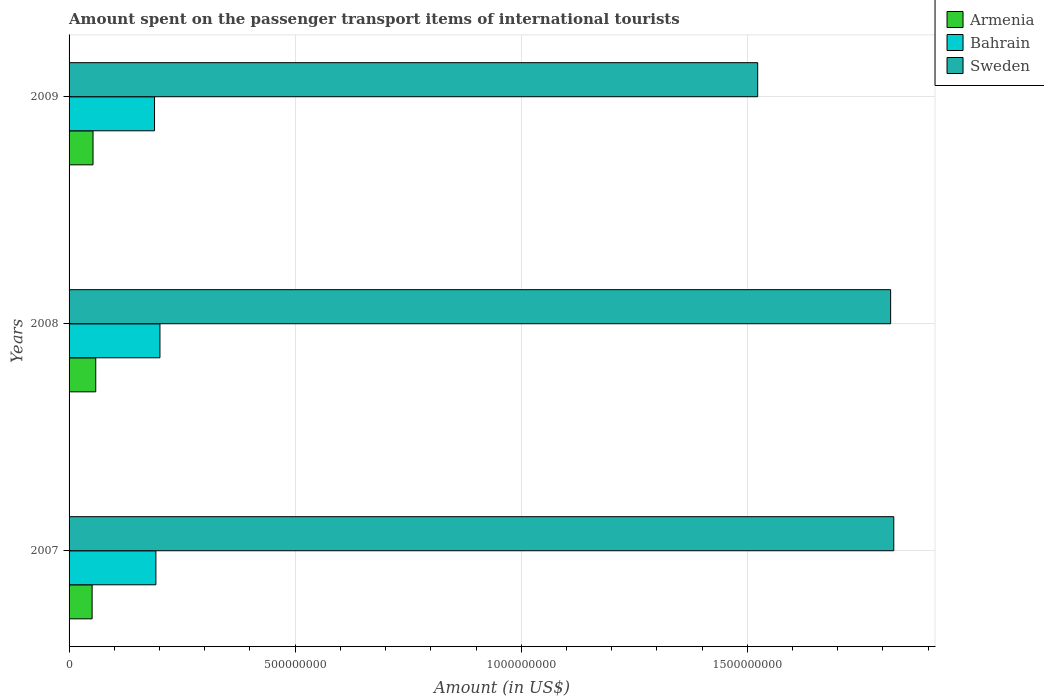How many different coloured bars are there?
Ensure brevity in your answer.  3. How many groups of bars are there?
Provide a short and direct response. 3. Are the number of bars per tick equal to the number of legend labels?
Your answer should be compact. Yes. Are the number of bars on each tick of the Y-axis equal?
Your response must be concise. Yes. How many bars are there on the 2nd tick from the top?
Your response must be concise. 3. How many bars are there on the 2nd tick from the bottom?
Your answer should be very brief. 3. In how many cases, is the number of bars for a given year not equal to the number of legend labels?
Your answer should be compact. 0. What is the amount spent on the passenger transport items of international tourists in Bahrain in 2009?
Provide a succinct answer. 1.89e+08. Across all years, what is the maximum amount spent on the passenger transport items of international tourists in Bahrain?
Your answer should be compact. 2.01e+08. Across all years, what is the minimum amount spent on the passenger transport items of international tourists in Armenia?
Provide a short and direct response. 5.10e+07. What is the total amount spent on the passenger transport items of international tourists in Sweden in the graph?
Your answer should be very brief. 5.16e+09. What is the difference between the amount spent on the passenger transport items of international tourists in Sweden in 2007 and that in 2009?
Provide a short and direct response. 3.01e+08. What is the difference between the amount spent on the passenger transport items of international tourists in Armenia in 2009 and the amount spent on the passenger transport items of international tourists in Bahrain in 2007?
Provide a succinct answer. -1.39e+08. What is the average amount spent on the passenger transport items of international tourists in Sweden per year?
Your answer should be very brief. 1.72e+09. In the year 2008, what is the difference between the amount spent on the passenger transport items of international tourists in Armenia and amount spent on the passenger transport items of international tourists in Sweden?
Provide a short and direct response. -1.76e+09. What is the ratio of the amount spent on the passenger transport items of international tourists in Bahrain in 2008 to that in 2009?
Your answer should be compact. 1.06. Is the difference between the amount spent on the passenger transport items of international tourists in Armenia in 2007 and 2009 greater than the difference between the amount spent on the passenger transport items of international tourists in Sweden in 2007 and 2009?
Offer a very short reply. No. What is the difference between the highest and the second highest amount spent on the passenger transport items of international tourists in Sweden?
Ensure brevity in your answer.  7.00e+06. What is the difference between the highest and the lowest amount spent on the passenger transport items of international tourists in Armenia?
Your answer should be very brief. 8.00e+06. In how many years, is the amount spent on the passenger transport items of international tourists in Sweden greater than the average amount spent on the passenger transport items of international tourists in Sweden taken over all years?
Provide a short and direct response. 2. What does the 1st bar from the top in 2008 represents?
Give a very brief answer. Sweden. What does the 1st bar from the bottom in 2007 represents?
Make the answer very short. Armenia. Is it the case that in every year, the sum of the amount spent on the passenger transport items of international tourists in Sweden and amount spent on the passenger transport items of international tourists in Bahrain is greater than the amount spent on the passenger transport items of international tourists in Armenia?
Your answer should be very brief. Yes. Are all the bars in the graph horizontal?
Make the answer very short. Yes. How many legend labels are there?
Your answer should be compact. 3. What is the title of the graph?
Provide a short and direct response. Amount spent on the passenger transport items of international tourists. What is the label or title of the X-axis?
Offer a terse response. Amount (in US$). What is the Amount (in US$) in Armenia in 2007?
Keep it short and to the point. 5.10e+07. What is the Amount (in US$) in Bahrain in 2007?
Provide a succinct answer. 1.92e+08. What is the Amount (in US$) of Sweden in 2007?
Make the answer very short. 1.82e+09. What is the Amount (in US$) of Armenia in 2008?
Keep it short and to the point. 5.90e+07. What is the Amount (in US$) of Bahrain in 2008?
Your response must be concise. 2.01e+08. What is the Amount (in US$) of Sweden in 2008?
Your answer should be very brief. 1.82e+09. What is the Amount (in US$) in Armenia in 2009?
Ensure brevity in your answer.  5.30e+07. What is the Amount (in US$) of Bahrain in 2009?
Provide a succinct answer. 1.89e+08. What is the Amount (in US$) in Sweden in 2009?
Offer a very short reply. 1.52e+09. Across all years, what is the maximum Amount (in US$) of Armenia?
Keep it short and to the point. 5.90e+07. Across all years, what is the maximum Amount (in US$) of Bahrain?
Make the answer very short. 2.01e+08. Across all years, what is the maximum Amount (in US$) in Sweden?
Keep it short and to the point. 1.82e+09. Across all years, what is the minimum Amount (in US$) in Armenia?
Provide a succinct answer. 5.10e+07. Across all years, what is the minimum Amount (in US$) of Bahrain?
Make the answer very short. 1.89e+08. Across all years, what is the minimum Amount (in US$) in Sweden?
Provide a short and direct response. 1.52e+09. What is the total Amount (in US$) of Armenia in the graph?
Provide a short and direct response. 1.63e+08. What is the total Amount (in US$) in Bahrain in the graph?
Give a very brief answer. 5.82e+08. What is the total Amount (in US$) in Sweden in the graph?
Your response must be concise. 5.16e+09. What is the difference between the Amount (in US$) in Armenia in 2007 and that in 2008?
Your response must be concise. -8.00e+06. What is the difference between the Amount (in US$) of Bahrain in 2007 and that in 2008?
Ensure brevity in your answer.  -9.00e+06. What is the difference between the Amount (in US$) of Sweden in 2007 and that in 2008?
Your answer should be very brief. 7.00e+06. What is the difference between the Amount (in US$) of Sweden in 2007 and that in 2009?
Make the answer very short. 3.01e+08. What is the difference between the Amount (in US$) of Armenia in 2008 and that in 2009?
Provide a succinct answer. 6.00e+06. What is the difference between the Amount (in US$) in Bahrain in 2008 and that in 2009?
Provide a short and direct response. 1.20e+07. What is the difference between the Amount (in US$) of Sweden in 2008 and that in 2009?
Provide a succinct answer. 2.94e+08. What is the difference between the Amount (in US$) of Armenia in 2007 and the Amount (in US$) of Bahrain in 2008?
Make the answer very short. -1.50e+08. What is the difference between the Amount (in US$) of Armenia in 2007 and the Amount (in US$) of Sweden in 2008?
Keep it short and to the point. -1.77e+09. What is the difference between the Amount (in US$) in Bahrain in 2007 and the Amount (in US$) in Sweden in 2008?
Offer a terse response. -1.62e+09. What is the difference between the Amount (in US$) in Armenia in 2007 and the Amount (in US$) in Bahrain in 2009?
Your answer should be very brief. -1.38e+08. What is the difference between the Amount (in US$) of Armenia in 2007 and the Amount (in US$) of Sweden in 2009?
Make the answer very short. -1.47e+09. What is the difference between the Amount (in US$) in Bahrain in 2007 and the Amount (in US$) in Sweden in 2009?
Make the answer very short. -1.33e+09. What is the difference between the Amount (in US$) in Armenia in 2008 and the Amount (in US$) in Bahrain in 2009?
Ensure brevity in your answer.  -1.30e+08. What is the difference between the Amount (in US$) in Armenia in 2008 and the Amount (in US$) in Sweden in 2009?
Offer a terse response. -1.46e+09. What is the difference between the Amount (in US$) of Bahrain in 2008 and the Amount (in US$) of Sweden in 2009?
Provide a short and direct response. -1.32e+09. What is the average Amount (in US$) of Armenia per year?
Provide a succinct answer. 5.43e+07. What is the average Amount (in US$) in Bahrain per year?
Provide a succinct answer. 1.94e+08. What is the average Amount (in US$) of Sweden per year?
Your response must be concise. 1.72e+09. In the year 2007, what is the difference between the Amount (in US$) in Armenia and Amount (in US$) in Bahrain?
Make the answer very short. -1.41e+08. In the year 2007, what is the difference between the Amount (in US$) of Armenia and Amount (in US$) of Sweden?
Give a very brief answer. -1.77e+09. In the year 2007, what is the difference between the Amount (in US$) in Bahrain and Amount (in US$) in Sweden?
Your response must be concise. -1.63e+09. In the year 2008, what is the difference between the Amount (in US$) in Armenia and Amount (in US$) in Bahrain?
Your answer should be very brief. -1.42e+08. In the year 2008, what is the difference between the Amount (in US$) in Armenia and Amount (in US$) in Sweden?
Make the answer very short. -1.76e+09. In the year 2008, what is the difference between the Amount (in US$) in Bahrain and Amount (in US$) in Sweden?
Your answer should be very brief. -1.62e+09. In the year 2009, what is the difference between the Amount (in US$) in Armenia and Amount (in US$) in Bahrain?
Provide a succinct answer. -1.36e+08. In the year 2009, what is the difference between the Amount (in US$) of Armenia and Amount (in US$) of Sweden?
Your response must be concise. -1.47e+09. In the year 2009, what is the difference between the Amount (in US$) of Bahrain and Amount (in US$) of Sweden?
Give a very brief answer. -1.33e+09. What is the ratio of the Amount (in US$) of Armenia in 2007 to that in 2008?
Make the answer very short. 0.86. What is the ratio of the Amount (in US$) of Bahrain in 2007 to that in 2008?
Provide a succinct answer. 0.96. What is the ratio of the Amount (in US$) of Sweden in 2007 to that in 2008?
Ensure brevity in your answer.  1. What is the ratio of the Amount (in US$) in Armenia in 2007 to that in 2009?
Ensure brevity in your answer.  0.96. What is the ratio of the Amount (in US$) in Bahrain in 2007 to that in 2009?
Offer a terse response. 1.02. What is the ratio of the Amount (in US$) in Sweden in 2007 to that in 2009?
Provide a succinct answer. 1.2. What is the ratio of the Amount (in US$) in Armenia in 2008 to that in 2009?
Your response must be concise. 1.11. What is the ratio of the Amount (in US$) in Bahrain in 2008 to that in 2009?
Your answer should be very brief. 1.06. What is the ratio of the Amount (in US$) of Sweden in 2008 to that in 2009?
Your answer should be compact. 1.19. What is the difference between the highest and the second highest Amount (in US$) in Bahrain?
Provide a short and direct response. 9.00e+06. What is the difference between the highest and the lowest Amount (in US$) of Armenia?
Offer a terse response. 8.00e+06. What is the difference between the highest and the lowest Amount (in US$) in Bahrain?
Your response must be concise. 1.20e+07. What is the difference between the highest and the lowest Amount (in US$) in Sweden?
Offer a very short reply. 3.01e+08. 